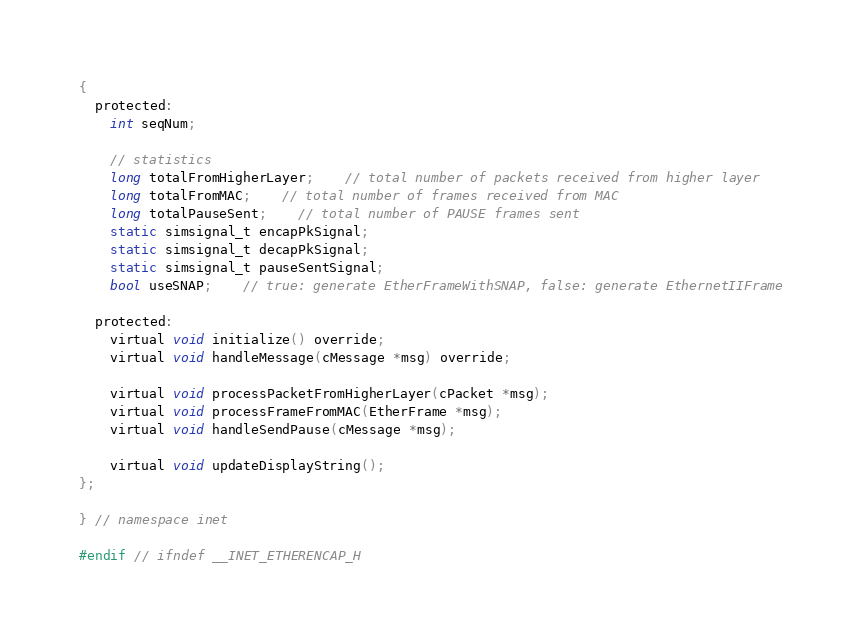<code> <loc_0><loc_0><loc_500><loc_500><_C_>{
  protected:
    int seqNum;

    // statistics
    long totalFromHigherLayer;    // total number of packets received from higher layer
    long totalFromMAC;    // total number of frames received from MAC
    long totalPauseSent;    // total number of PAUSE frames sent
    static simsignal_t encapPkSignal;
    static simsignal_t decapPkSignal;
    static simsignal_t pauseSentSignal;
    bool useSNAP;    // true: generate EtherFrameWithSNAP, false: generate EthernetIIFrame

  protected:
    virtual void initialize() override;
    virtual void handleMessage(cMessage *msg) override;

    virtual void processPacketFromHigherLayer(cPacket *msg);
    virtual void processFrameFromMAC(EtherFrame *msg);
    virtual void handleSendPause(cMessage *msg);

    virtual void updateDisplayString();
};

} // namespace inet

#endif // ifndef __INET_ETHERENCAP_H

</code> 